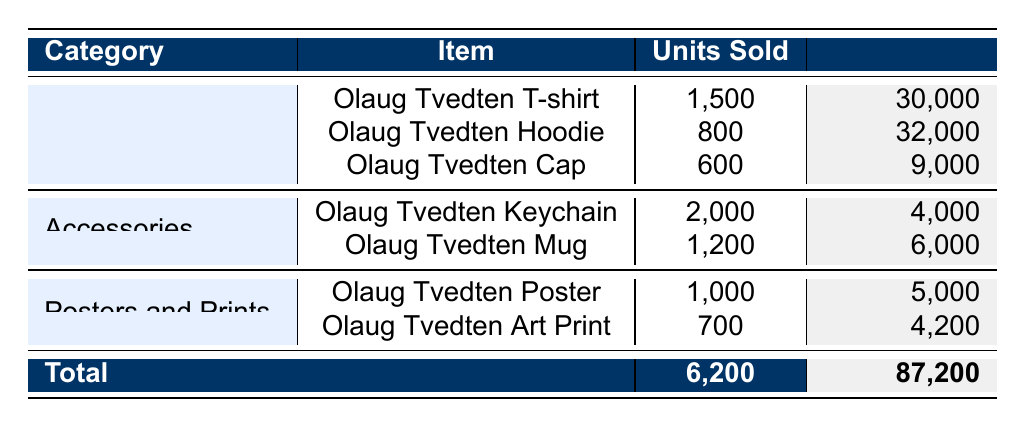What is the total revenue generated from the Olaug Tvedten Hoodie? The table shows that the revenue for the Olaug Tvedten Hoodie is directly listed as $32,000.
Answer: 32000 Which item had the highest units sold in the Accessories category? The table lists units sold for each item in the Accessories category: 2,000 for the Olaug Tvedten Keychain and 1,200 for the Olaug Tvedten Mug. The highest amount is 2,000 for the Keychain.
Answer: Olaug Tvedten Keychain What is the total number of units sold in the Apparel category? The units sold in the Apparel category are: 1,500 (T-shirt) + 800 (Hoodie) + 600 (Cap), summing up to 1,500 + 800 + 600 = 2,900 units sold.
Answer: 2900 Did Olaug Tvedten sell more than 2,500 units in Accessories? The total units sold in the Accessories category are 2,000 (Keychain) + 1,200 (Mug), which equals 3,200 units, thus confirming that more than 2,500 units were sold.
Answer: Yes What is the average revenue for items under the Posters and Prints category? The revenue for the items in this category is $5,000 (Poster) + $4,200 (Art Print) = $9,200 total. Since there are two items, the average revenue is $9,200 / 2 = $4,600.
Answer: 4600 How much revenue did the Olaug Tvedten Cap generate? The table shows the revenue for the Olaug Tvedten Cap is listed directly as $9,000.
Answer: 9000 What is the total revenue across all merchandise categories? The total revenue is given as $87,200 in the total sales row of the table.
Answer: 87200 What percentage of total sales revenue was made from the Apparel category? The total revenue from the Apparel category is $30,000 + $32,000 + $9,000 = $71,000. To find the percentage, the calculation is ($71,000 / $87,200) * 100, which equals approximately 81.3%.
Answer: 81.3% Did the total units sold for Merchandise exceed 6,000? The total units sold across all categories is explicitly stated as 6,200, which exceeds 6,000.
Answer: Yes 